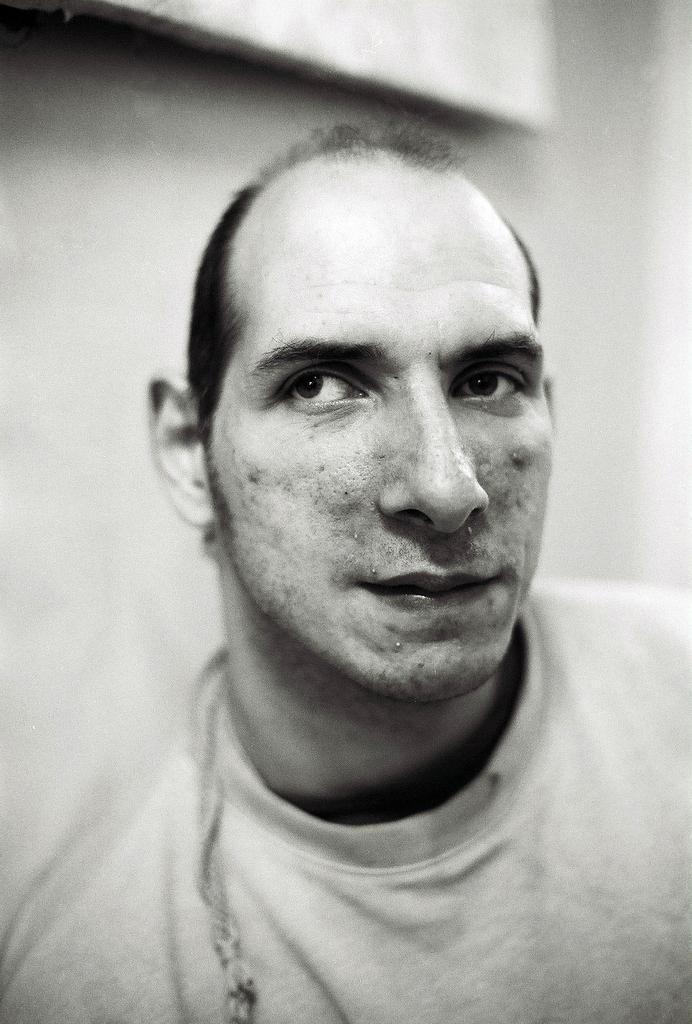How would you summarize this image in a sentence or two? In this image in the center there is one man, and in the background there is a wall. 